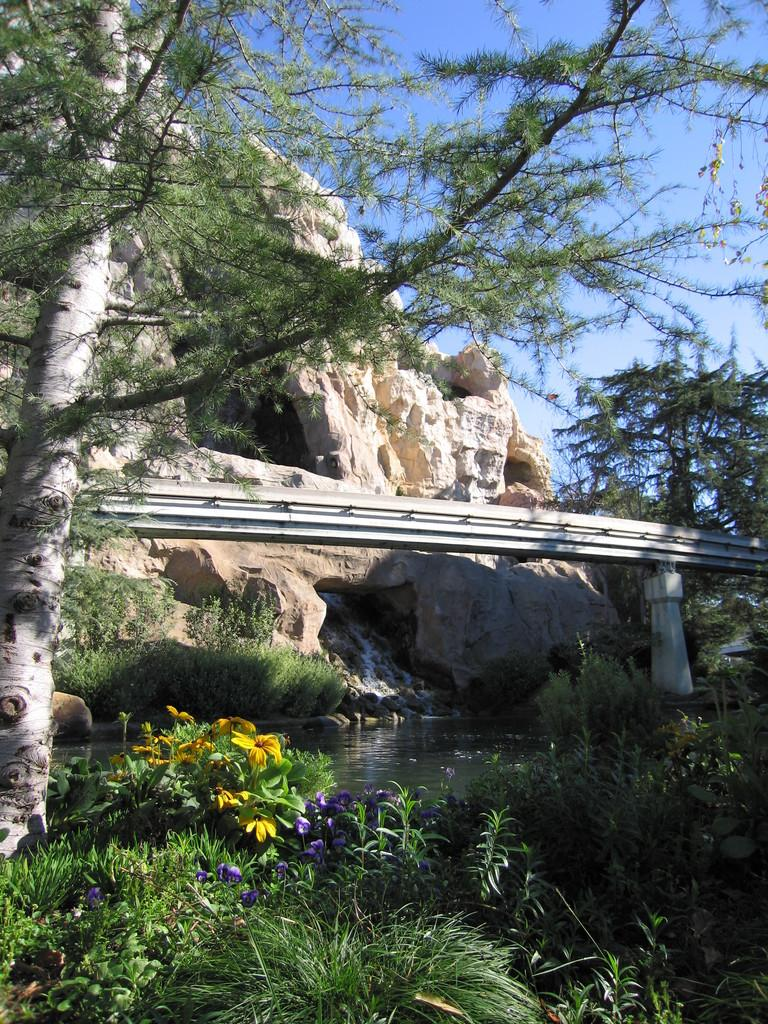What type of living organisms can be seen in the image? Plants can be seen in the image. What is visible in the image besides plants? There is water, a bridge, trees, rocks, and the sky visible in the image. Where is the bridge located in the image? The bridge is in the center of the image. What can be seen in the background of the image? Trees, rocks, and the sky can be seen in the background of the image. Can you see the smile on the fairies in the image? There are no fairies present in the image, so it is not possible to see a smile on them. What type of bread can be seen in the image? There is no bread, specifically a loaf, present in the image. 